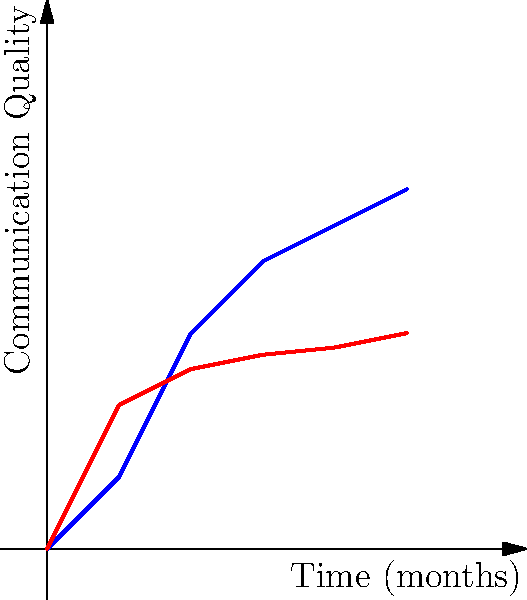Based on the communication style chart showing the quality of communication over time for two partners in a relationship, which partner is more likely to contribute to a healthier relationship dynamic, and why? To answer this question, we need to analyze the communication patterns of both partners:

1. Partner A (Blue Line):
   - Shows a steady increase in communication quality over time
   - Starts at 0 and reaches 5 on the quality scale
   - The curve is steeper, indicating faster improvement

2. Partner B (Red Line):
   - Shows some improvement in communication quality, but less pronounced
   - Starts at 0 and reaches only about 3 on the quality scale
   - The curve flattens out, suggesting slower or stagnating improvement

3. Comparing the two:
   - Partner A demonstrates more significant growth in communication quality
   - Partner A's communication quality surpasses Partner B's by the end of the time period
   - Partner A's trajectory suggests continued improvement, while Partner B's seems to plateau

4. Importance of communication in relationships:
   - Open, honest, and improving communication is crucial for healthy relationships
   - The ability to enhance communication over time indicates emotional intelligence and effort

5. Conclusion:
   Partner A is more likely to contribute to a healthier relationship dynamic because they show:
   a) Greater improvement in communication quality
   b) Higher overall communication quality by the end of the period
   c) A trend suggesting continued growth and effort in communication

This pattern indicates that Partner A is more likely to address issues, work on self-improvement, and maintain open lines of communication, which are essential for overcoming challenges and building a strong, healthy relationship.
Answer: Partner A, due to greater improvement and higher overall communication quality. 